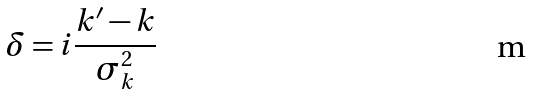<formula> <loc_0><loc_0><loc_500><loc_500>\delta = i \frac { k ^ { \prime } - k } { \sigma _ { k } ^ { 2 } }</formula> 